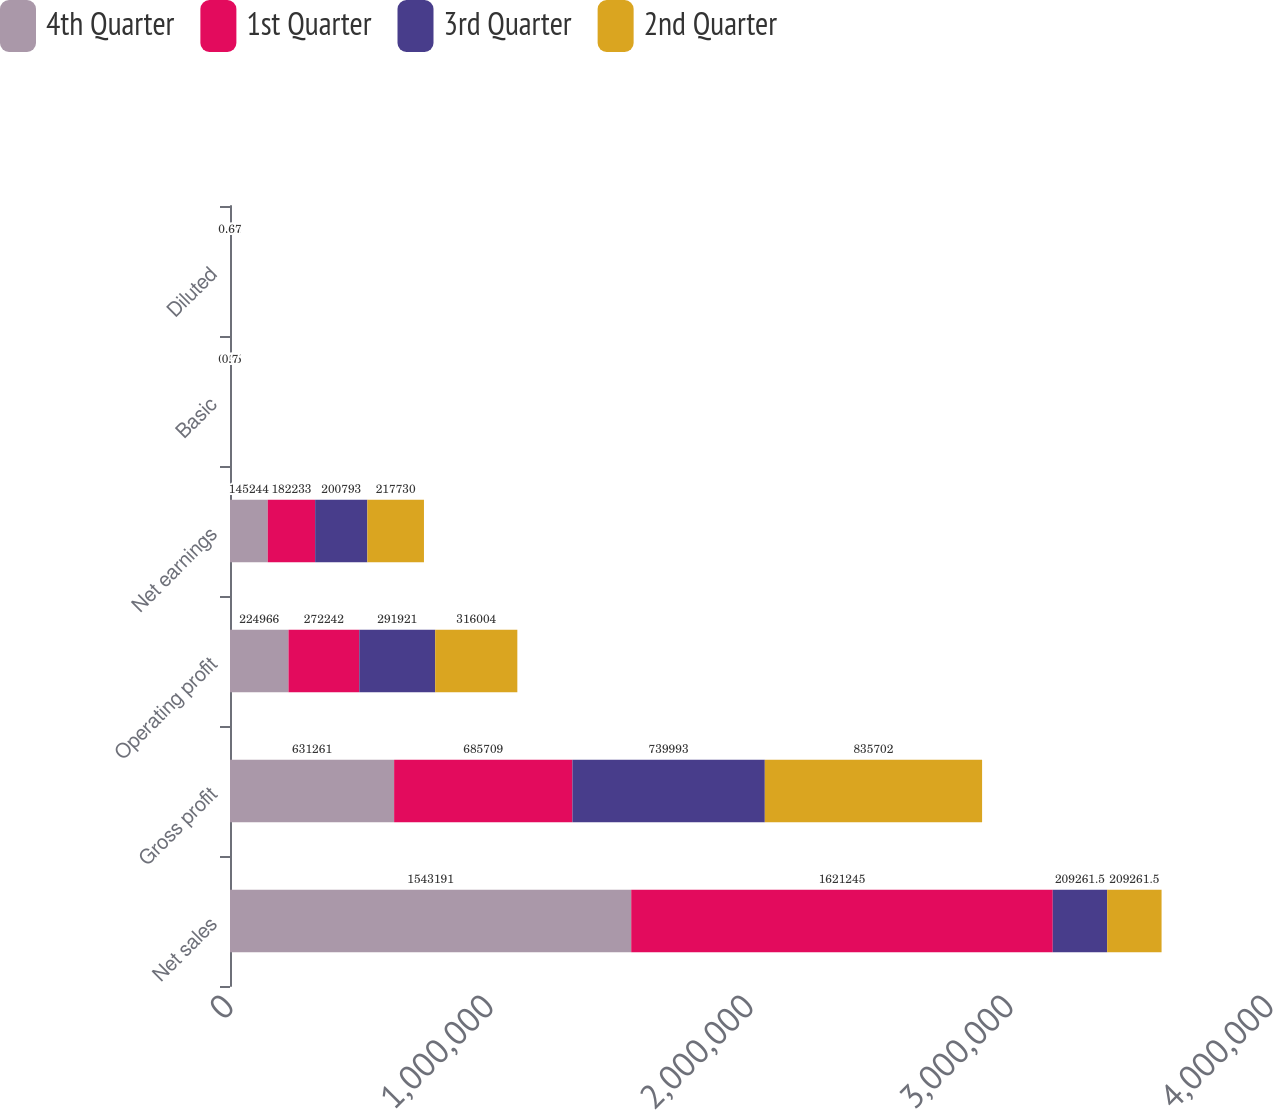Convert chart. <chart><loc_0><loc_0><loc_500><loc_500><stacked_bar_chart><ecel><fcel>Net sales<fcel>Gross profit<fcel>Operating profit<fcel>Net earnings<fcel>Basic<fcel>Diluted<nl><fcel>4th Quarter<fcel>1.54319e+06<fcel>631261<fcel>224966<fcel>145244<fcel>0.47<fcel>0.45<nl><fcel>1st Quarter<fcel>1.62124e+06<fcel>685709<fcel>272242<fcel>182233<fcel>0.59<fcel>0.56<nl><fcel>3rd Quarter<fcel>209262<fcel>739993<fcel>291921<fcel>200793<fcel>0.65<fcel>0.62<nl><fcel>2nd Quarter<fcel>209262<fcel>835702<fcel>316004<fcel>217730<fcel>0.7<fcel>0.67<nl></chart> 